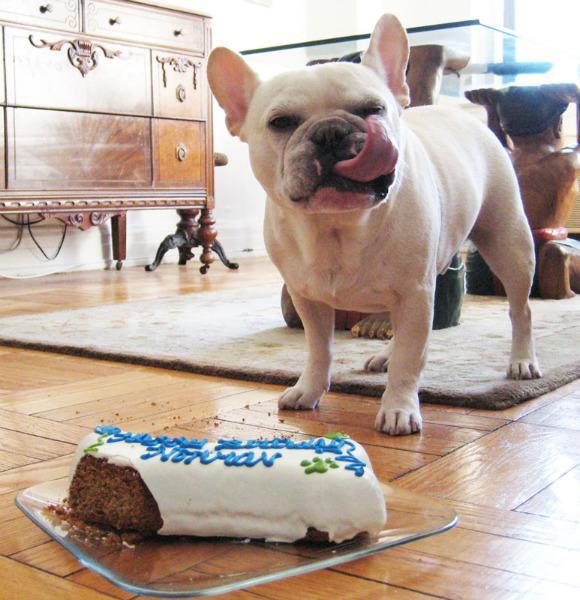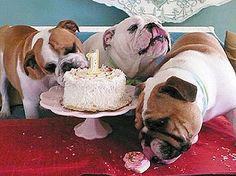The first image is the image on the left, the second image is the image on the right. For the images shown, is this caption "The head of a dark big-eared dog is behind a container of fresh red fruit." true? Answer yes or no. No. The first image is the image on the left, the second image is the image on the right. For the images shown, is this caption "There is a serving of fresh fruit in front of a black puppy." true? Answer yes or no. No. 